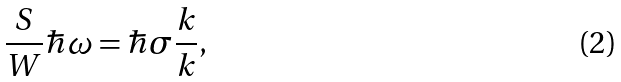<formula> <loc_0><loc_0><loc_500><loc_500>\frac { S } { W } \hbar { \omega } = \hbar { \sigma } \frac { k } { k } ,</formula> 